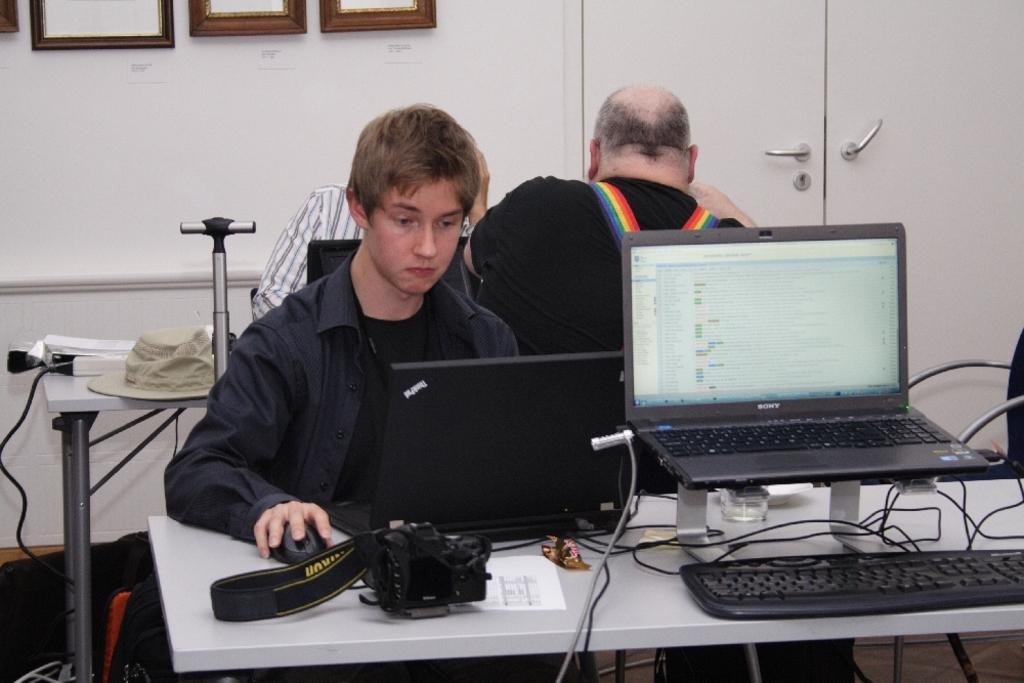Please provide a concise description of this image. In this picture I can see three persons sitting on the chairs, there are laptops, keyboard, hat, paper, cables, camera and some other objects on the tables, and in the background there are frames attached to the wall and there are doors. 